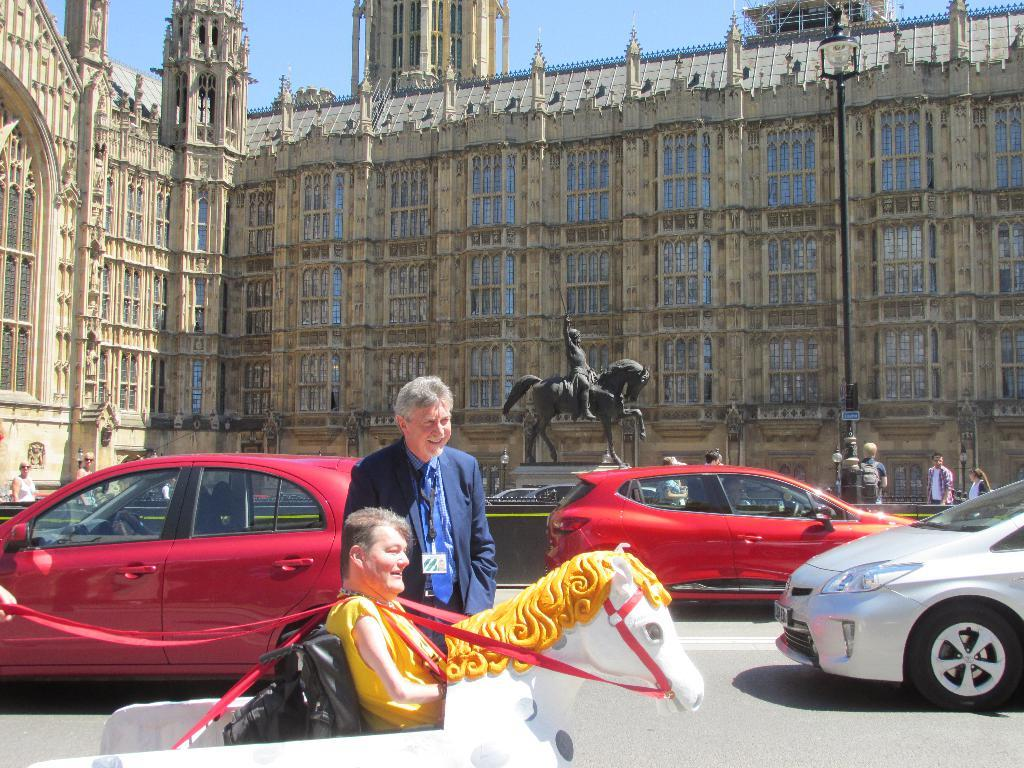Where was the image taken? The image is taken on the road. What can be seen in the center of the image? There is a man standing in the center of the image. What type of vehicles are present in the image? There are cars in the image. What can be seen in the background of the image? There is a statue and a building in the background of the image, as well as the sky. What type of body is visible in the image? There is no body present in the image; it features a man standing on the road with cars, a statue, a building, and the sky in the background. Where is the lunchroom located in the image? There is no lunchroom present in the image. 